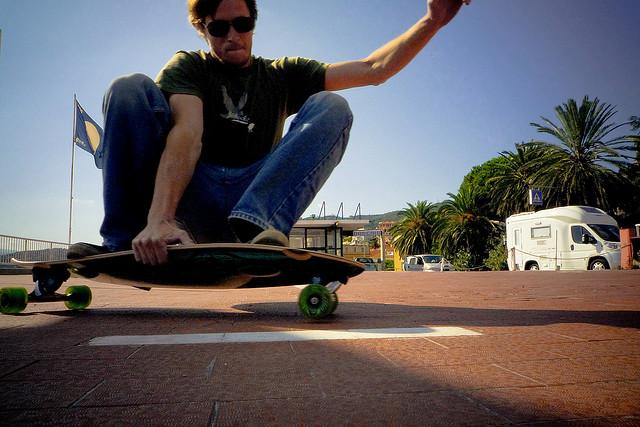Is this person in the air or on the ground?
Be succinct. Ground. What color is the camper in the scene?
Keep it brief. White. Is the man wearing sunglasses?
Write a very short answer. Yes. Why is the skateboards wheels green?
Concise answer only. To match board. 